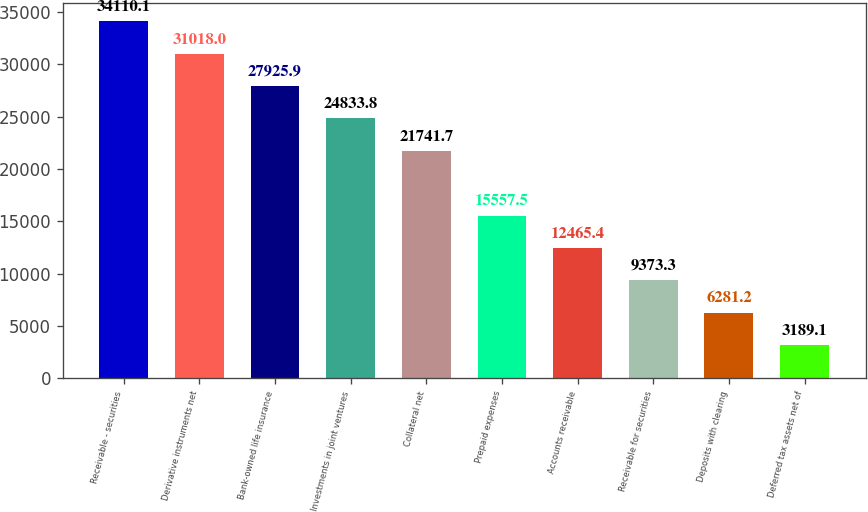<chart> <loc_0><loc_0><loc_500><loc_500><bar_chart><fcel>Receivable - securities<fcel>Derivative instruments net<fcel>Bank-owned life insurance<fcel>Investments in joint ventures<fcel>Collateral net<fcel>Prepaid expenses<fcel>Accounts receivable<fcel>Receivable for securities<fcel>Deposits with clearing<fcel>Deferred tax assets net of<nl><fcel>34110.1<fcel>31018<fcel>27925.9<fcel>24833.8<fcel>21741.7<fcel>15557.5<fcel>12465.4<fcel>9373.3<fcel>6281.2<fcel>3189.1<nl></chart> 